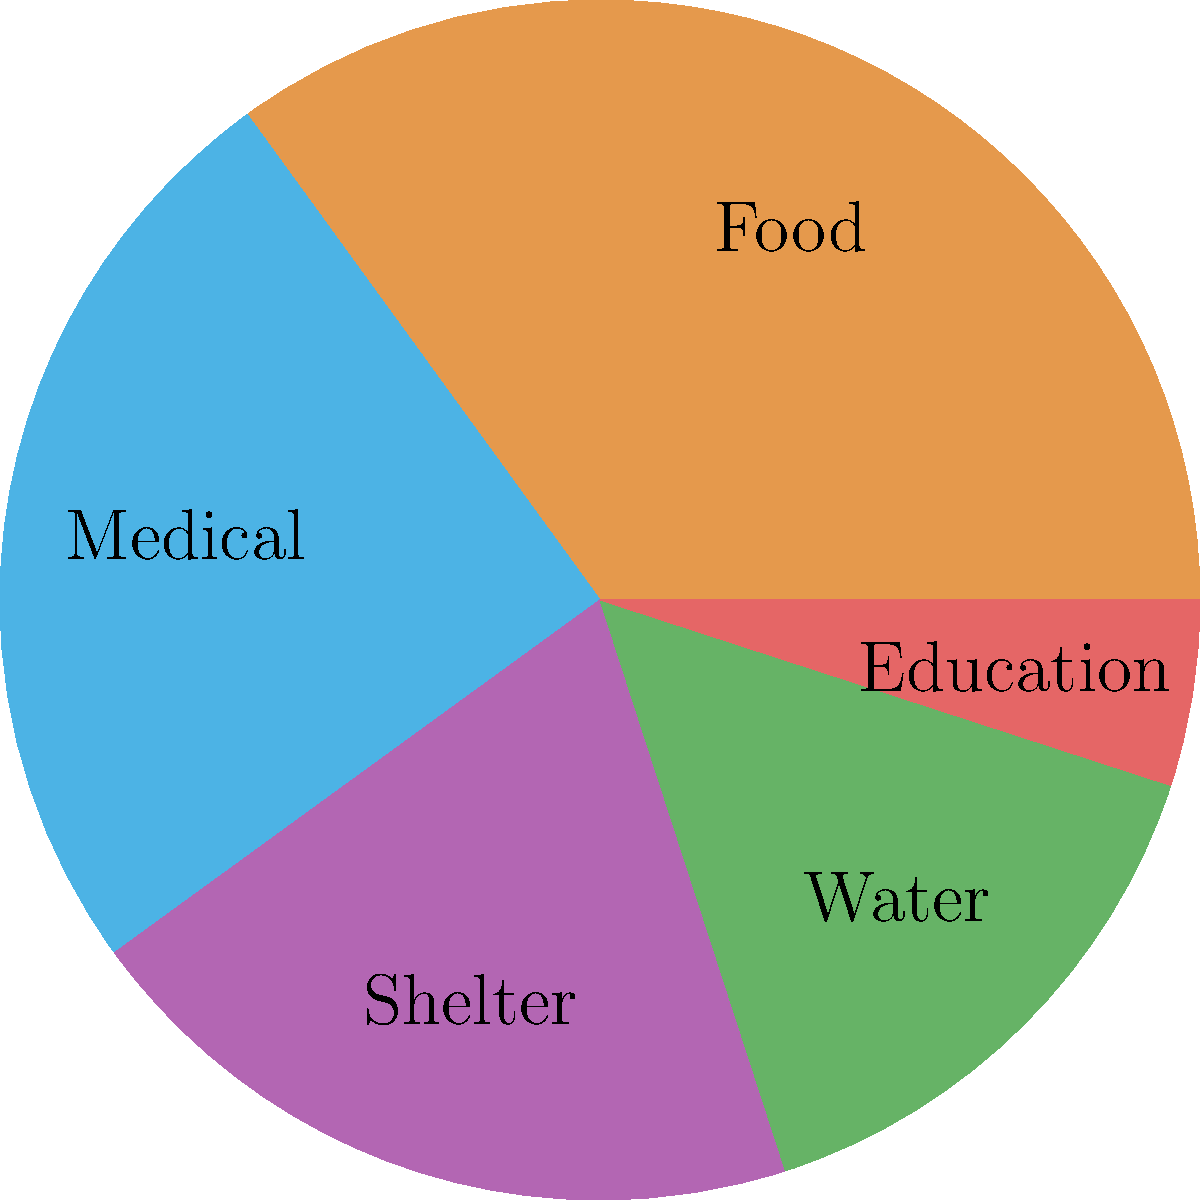As a war survivor, you've witnessed the distribution of aid resources in your community. The pie chart shows the allocation of assistance across different categories. Which category receives the second-largest share of aid resources, and what percentage does it represent? To answer this question, we need to analyze the pie chart and follow these steps:

1. Identify all categories and their corresponding percentages:
   - Food: 35%
   - Medical: 25%
   - Shelter: 20%
   - Water: 15%
   - Education: 5%

2. Order the categories from largest to smallest:
   1. Food (35%)
   2. Medical (25%)
   3. Shelter (20%)
   4. Water (15%)
   5. Education (5%)

3. Identify the second-largest category:
   The second-largest category is Medical aid.

4. Determine the percentage for the Medical aid category:
   Medical aid represents 25% of the total aid resources.

Therefore, the second-largest share of aid resources is allocated to Medical assistance, representing 25% of the total aid distribution.
Answer: Medical, 25% 